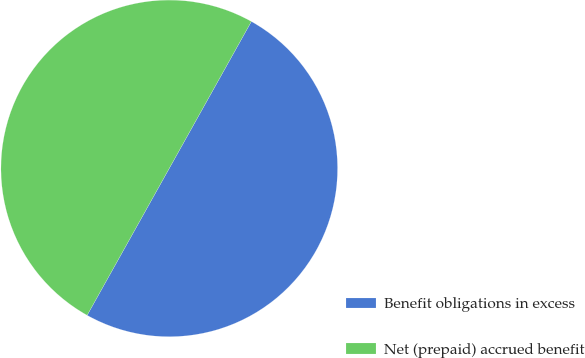Convert chart to OTSL. <chart><loc_0><loc_0><loc_500><loc_500><pie_chart><fcel>Benefit obligations in excess<fcel>Net (prepaid) accrued benefit<nl><fcel>50.0%<fcel>50.0%<nl></chart> 